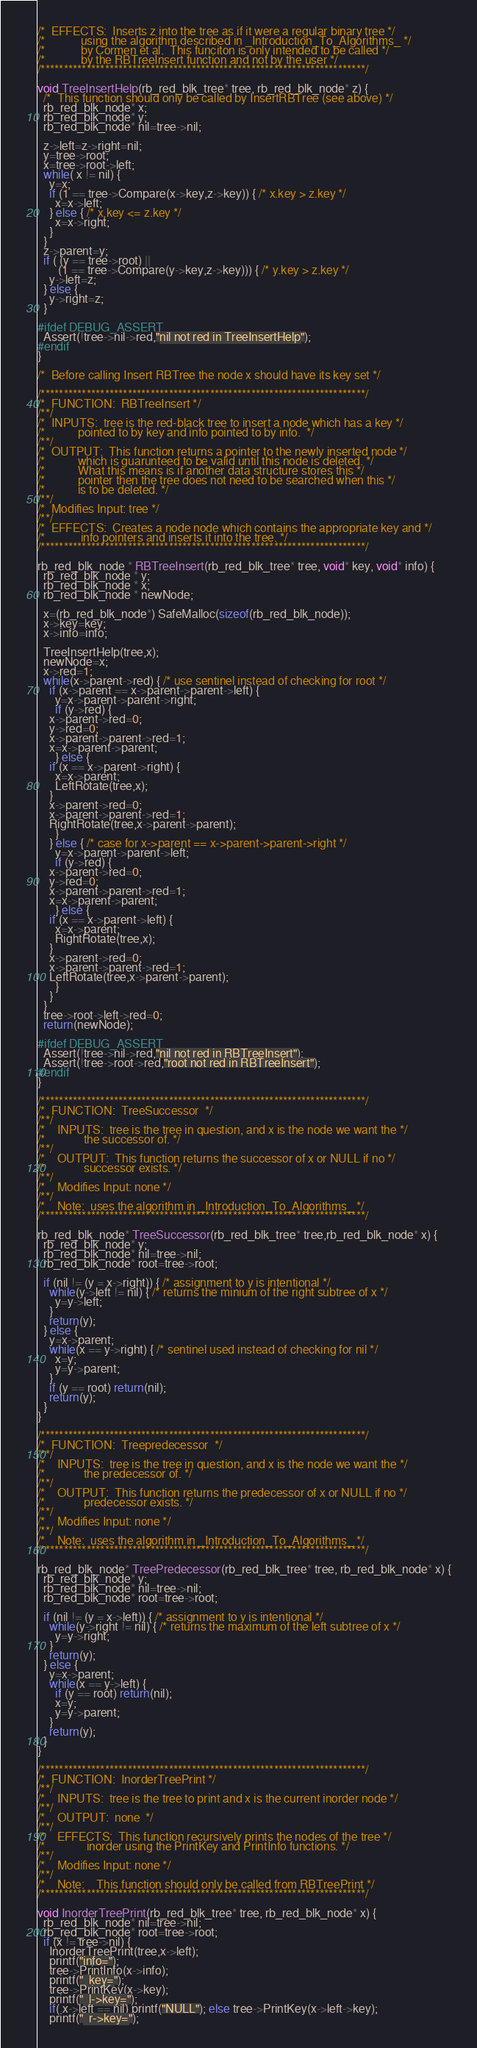<code> <loc_0><loc_0><loc_500><loc_500><_C_>/*  EFFECTS:  Inserts z into the tree as if it were a regular binary tree */
/*            using the algorithm described in _Introduction_To_Algorithms_ */
/*            by Cormen et al.  This funciton is only intended to be called */
/*            by the RBTreeInsert function and not by the user */
/***********************************************************************/

void TreeInsertHelp(rb_red_blk_tree* tree, rb_red_blk_node* z) {
  /*  This function should only be called by InsertRBTree (see above) */
  rb_red_blk_node* x;
  rb_red_blk_node* y;
  rb_red_blk_node* nil=tree->nil;
  
  z->left=z->right=nil;
  y=tree->root;
  x=tree->root->left;
  while( x != nil) {
    y=x;
    if (1 == tree->Compare(x->key,z->key)) { /* x.key > z.key */
      x=x->left;
    } else { /* x,key <= z.key */
      x=x->right;
    }
  }
  z->parent=y;
  if ( (y == tree->root) ||
       (1 == tree->Compare(y->key,z->key))) { /* y.key > z.key */
    y->left=z;
  } else {
    y->right=z;
  }

#ifdef DEBUG_ASSERT
  Assert(!tree->nil->red,"nil not red in TreeInsertHelp");
#endif
}

/*  Before calling Insert RBTree the node x should have its key set */

/***********************************************************************/
/*  FUNCTION:  RBTreeInsert */
/**/
/*  INPUTS:  tree is the red-black tree to insert a node which has a key */
/*           pointed to by key and info pointed to by info.  */
/**/
/*  OUTPUT:  This function returns a pointer to the newly inserted node */
/*           which is guarunteed to be valid until this node is deleted. */
/*           What this means is if another data structure stores this */
/*           pointer then the tree does not need to be searched when this */
/*           is to be deleted. */
/**/
/*  Modifies Input: tree */
/**/
/*  EFFECTS:  Creates a node node which contains the appropriate key and */
/*            info pointers and inserts it into the tree. */
/***********************************************************************/

rb_red_blk_node * RBTreeInsert(rb_red_blk_tree* tree, void* key, void* info) {
  rb_red_blk_node * y;
  rb_red_blk_node * x;
  rb_red_blk_node * newNode;

  x=(rb_red_blk_node*) SafeMalloc(sizeof(rb_red_blk_node));
  x->key=key;
  x->info=info;

  TreeInsertHelp(tree,x);
  newNode=x;
  x->red=1;
  while(x->parent->red) { /* use sentinel instead of checking for root */
    if (x->parent == x->parent->parent->left) {
      y=x->parent->parent->right;
      if (y->red) {
	x->parent->red=0;
	y->red=0;
	x->parent->parent->red=1;
	x=x->parent->parent;
      } else {
	if (x == x->parent->right) {
	  x=x->parent;
	  LeftRotate(tree,x);
	}
	x->parent->red=0;
	x->parent->parent->red=1;
	RightRotate(tree,x->parent->parent);
      } 
    } else { /* case for x->parent == x->parent->parent->right */
      y=x->parent->parent->left;
      if (y->red) {
	x->parent->red=0;
	y->red=0;
	x->parent->parent->red=1;
	x=x->parent->parent;
      } else {
	if (x == x->parent->left) {
	  x=x->parent;
	  RightRotate(tree,x);
	}
	x->parent->red=0;
	x->parent->parent->red=1;
	LeftRotate(tree,x->parent->parent);
      } 
    }
  }
  tree->root->left->red=0;
  return(newNode);

#ifdef DEBUG_ASSERT
  Assert(!tree->nil->red,"nil not red in RBTreeInsert");
  Assert(!tree->root->red,"root not red in RBTreeInsert");
#endif
}

/***********************************************************************/
/*  FUNCTION:  TreeSuccessor  */
/**/
/*    INPUTS:  tree is the tree in question, and x is the node we want the */
/*             the successor of. */
/**/
/*    OUTPUT:  This function returns the successor of x or NULL if no */
/*             successor exists. */
/**/
/*    Modifies Input: none */
/**/
/*    Note:  uses the algorithm in _Introduction_To_Algorithms_ */
/***********************************************************************/
  
rb_red_blk_node* TreeSuccessor(rb_red_blk_tree* tree,rb_red_blk_node* x) { 
  rb_red_blk_node* y;
  rb_red_blk_node* nil=tree->nil;
  rb_red_blk_node* root=tree->root;

  if (nil != (y = x->right)) { /* assignment to y is intentional */
    while(y->left != nil) { /* returns the minium of the right subtree of x */
      y=y->left;
    }
    return(y);
  } else {
    y=x->parent;
    while(x == y->right) { /* sentinel used instead of checking for nil */
      x=y;
      y=y->parent;
    }
    if (y == root) return(nil);
    return(y);
  }
}

/***********************************************************************/
/*  FUNCTION:  Treepredecessor  */
/**/
/*    INPUTS:  tree is the tree in question, and x is the node we want the */
/*             the predecessor of. */
/**/
/*    OUTPUT:  This function returns the predecessor of x or NULL if no */
/*             predecessor exists. */
/**/
/*    Modifies Input: none */
/**/
/*    Note:  uses the algorithm in _Introduction_To_Algorithms_ */
/***********************************************************************/

rb_red_blk_node* TreePredecessor(rb_red_blk_tree* tree, rb_red_blk_node* x) {
  rb_red_blk_node* y;
  rb_red_blk_node* nil=tree->nil;
  rb_red_blk_node* root=tree->root;

  if (nil != (y = x->left)) { /* assignment to y is intentional */
    while(y->right != nil) { /* returns the maximum of the left subtree of x */
      y=y->right;
    }
    return(y);
  } else {
    y=x->parent;
    while(x == y->left) { 
      if (y == root) return(nil); 
      x=y;
      y=y->parent;
    }
    return(y);
  }
}

/***********************************************************************/
/*  FUNCTION:  InorderTreePrint */
/**/
/*    INPUTS:  tree is the tree to print and x is the current inorder node */
/**/
/*    OUTPUT:  none  */
/**/
/*    EFFECTS:  This function recursively prints the nodes of the tree */
/*              inorder using the PrintKey and PrintInfo functions. */
/**/
/*    Modifies Input: none */
/**/
/*    Note:    This function should only be called from RBTreePrint */
/***********************************************************************/

void InorderTreePrint(rb_red_blk_tree* tree, rb_red_blk_node* x) {
  rb_red_blk_node* nil=tree->nil;
  rb_red_blk_node* root=tree->root;
  if (x != tree->nil) {
    InorderTreePrint(tree,x->left);
    printf("info=");
    tree->PrintInfo(x->info);
    printf("  key="); 
    tree->PrintKey(x->key);
    printf("  l->key=");
    if( x->left == nil) printf("NULL"); else tree->PrintKey(x->left->key);
    printf("  r->key=");</code> 